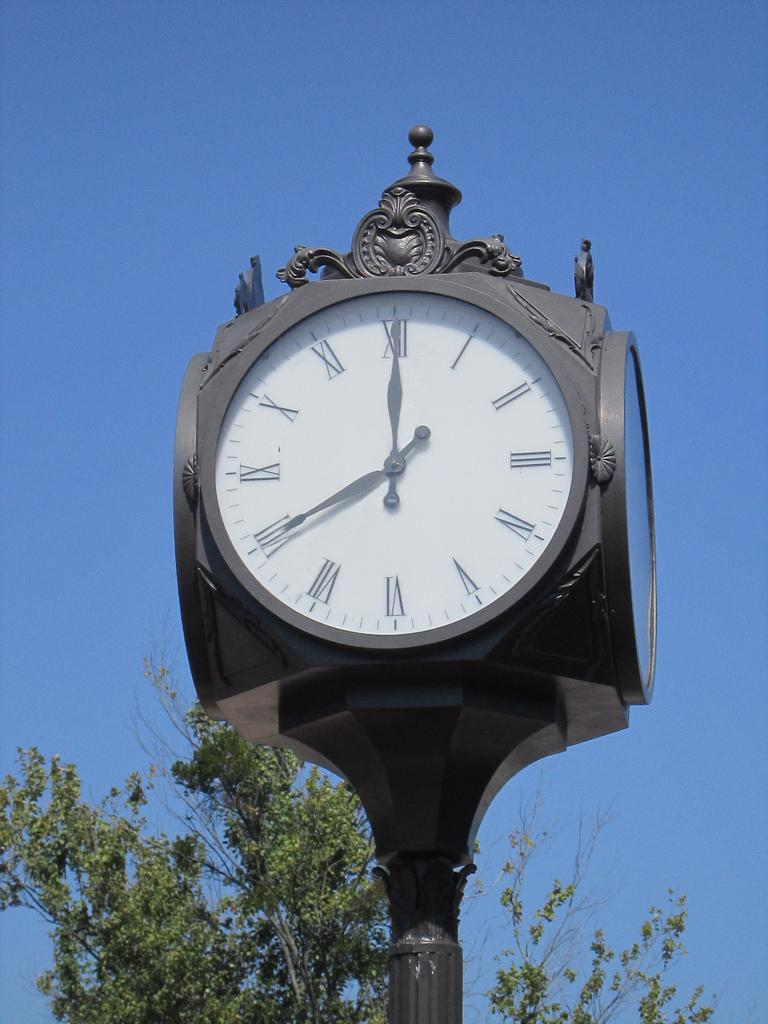Provide a one-sentence caption for the provided image. a street clock that says seven o'clock on it. 